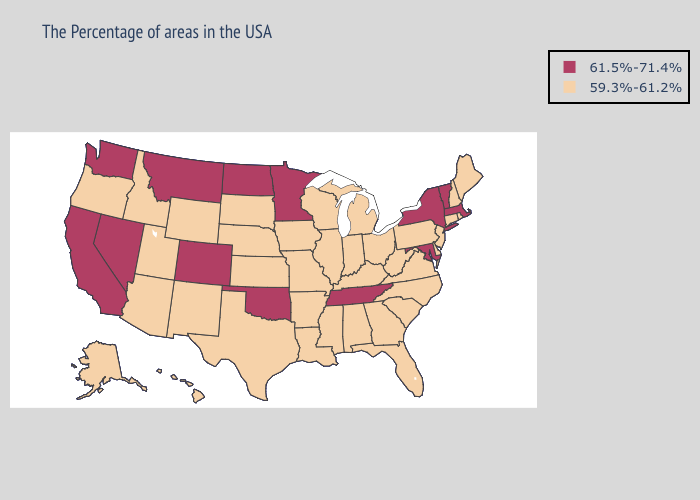What is the value of Mississippi?
Be succinct. 59.3%-61.2%. What is the lowest value in the South?
Write a very short answer. 59.3%-61.2%. Does Vermont have the highest value in the Northeast?
Concise answer only. Yes. Does Texas have a lower value than Georgia?
Keep it brief. No. Does Tennessee have the highest value in the South?
Concise answer only. Yes. Name the states that have a value in the range 61.5%-71.4%?
Give a very brief answer. Massachusetts, Vermont, New York, Maryland, Tennessee, Minnesota, Oklahoma, North Dakota, Colorado, Montana, Nevada, California, Washington. Among the states that border Nebraska , which have the lowest value?
Answer briefly. Missouri, Iowa, Kansas, South Dakota, Wyoming. Name the states that have a value in the range 61.5%-71.4%?
Short answer required. Massachusetts, Vermont, New York, Maryland, Tennessee, Minnesota, Oklahoma, North Dakota, Colorado, Montana, Nevada, California, Washington. Name the states that have a value in the range 61.5%-71.4%?
Be succinct. Massachusetts, Vermont, New York, Maryland, Tennessee, Minnesota, Oklahoma, North Dakota, Colorado, Montana, Nevada, California, Washington. What is the value of Oregon?
Write a very short answer. 59.3%-61.2%. Is the legend a continuous bar?
Concise answer only. No. Does Oklahoma have the lowest value in the South?
Concise answer only. No. Name the states that have a value in the range 59.3%-61.2%?
Answer briefly. Maine, Rhode Island, New Hampshire, Connecticut, New Jersey, Delaware, Pennsylvania, Virginia, North Carolina, South Carolina, West Virginia, Ohio, Florida, Georgia, Michigan, Kentucky, Indiana, Alabama, Wisconsin, Illinois, Mississippi, Louisiana, Missouri, Arkansas, Iowa, Kansas, Nebraska, Texas, South Dakota, Wyoming, New Mexico, Utah, Arizona, Idaho, Oregon, Alaska, Hawaii. What is the value of Arkansas?
Keep it brief. 59.3%-61.2%. Name the states that have a value in the range 59.3%-61.2%?
Short answer required. Maine, Rhode Island, New Hampshire, Connecticut, New Jersey, Delaware, Pennsylvania, Virginia, North Carolina, South Carolina, West Virginia, Ohio, Florida, Georgia, Michigan, Kentucky, Indiana, Alabama, Wisconsin, Illinois, Mississippi, Louisiana, Missouri, Arkansas, Iowa, Kansas, Nebraska, Texas, South Dakota, Wyoming, New Mexico, Utah, Arizona, Idaho, Oregon, Alaska, Hawaii. 